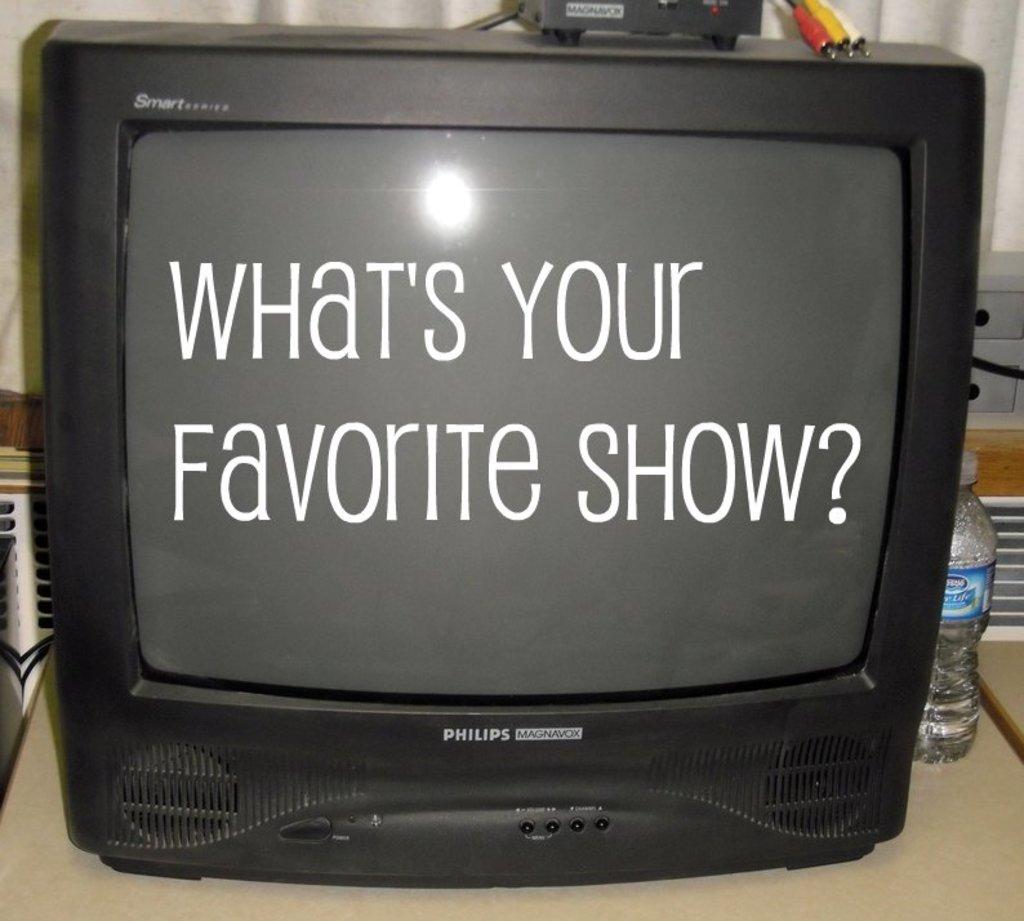What does the tv say?
Give a very brief answer. What's your favorite show?. What kind of tv is this?
Your answer should be very brief. Philips. 